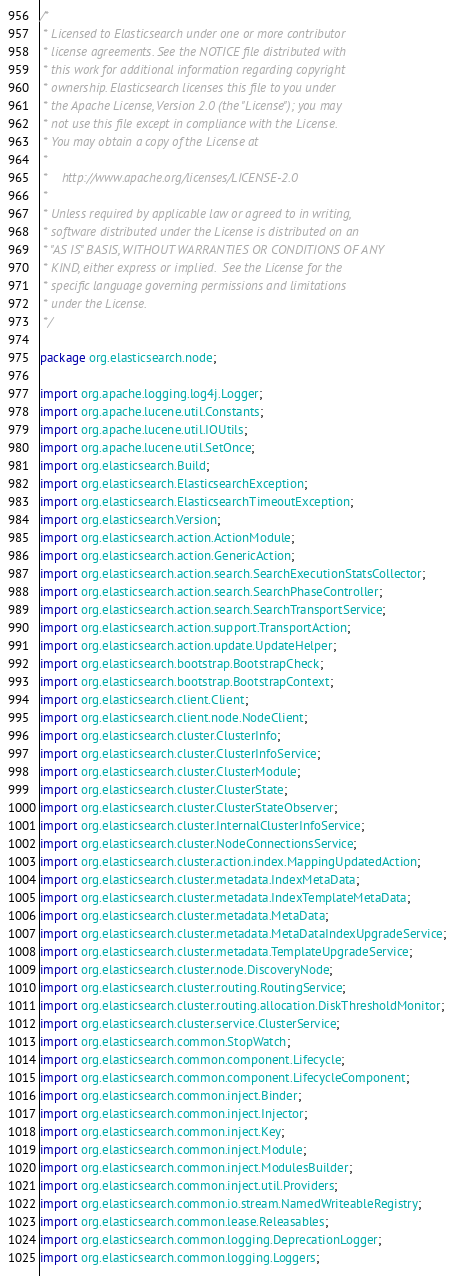Convert code to text. <code><loc_0><loc_0><loc_500><loc_500><_Java_>/*
 * Licensed to Elasticsearch under one or more contributor
 * license agreements. See the NOTICE file distributed with
 * this work for additional information regarding copyright
 * ownership. Elasticsearch licenses this file to you under
 * the Apache License, Version 2.0 (the "License"); you may
 * not use this file except in compliance with the License.
 * You may obtain a copy of the License at
 *
 *    http://www.apache.org/licenses/LICENSE-2.0
 *
 * Unless required by applicable law or agreed to in writing,
 * software distributed under the License is distributed on an
 * "AS IS" BASIS, WITHOUT WARRANTIES OR CONDITIONS OF ANY
 * KIND, either express or implied.  See the License for the
 * specific language governing permissions and limitations
 * under the License.
 */

package org.elasticsearch.node;

import org.apache.logging.log4j.Logger;
import org.apache.lucene.util.Constants;
import org.apache.lucene.util.IOUtils;
import org.apache.lucene.util.SetOnce;
import org.elasticsearch.Build;
import org.elasticsearch.ElasticsearchException;
import org.elasticsearch.ElasticsearchTimeoutException;
import org.elasticsearch.Version;
import org.elasticsearch.action.ActionModule;
import org.elasticsearch.action.GenericAction;
import org.elasticsearch.action.search.SearchExecutionStatsCollector;
import org.elasticsearch.action.search.SearchPhaseController;
import org.elasticsearch.action.search.SearchTransportService;
import org.elasticsearch.action.support.TransportAction;
import org.elasticsearch.action.update.UpdateHelper;
import org.elasticsearch.bootstrap.BootstrapCheck;
import org.elasticsearch.bootstrap.BootstrapContext;
import org.elasticsearch.client.Client;
import org.elasticsearch.client.node.NodeClient;
import org.elasticsearch.cluster.ClusterInfo;
import org.elasticsearch.cluster.ClusterInfoService;
import org.elasticsearch.cluster.ClusterModule;
import org.elasticsearch.cluster.ClusterState;
import org.elasticsearch.cluster.ClusterStateObserver;
import org.elasticsearch.cluster.InternalClusterInfoService;
import org.elasticsearch.cluster.NodeConnectionsService;
import org.elasticsearch.cluster.action.index.MappingUpdatedAction;
import org.elasticsearch.cluster.metadata.IndexMetaData;
import org.elasticsearch.cluster.metadata.IndexTemplateMetaData;
import org.elasticsearch.cluster.metadata.MetaData;
import org.elasticsearch.cluster.metadata.MetaDataIndexUpgradeService;
import org.elasticsearch.cluster.metadata.TemplateUpgradeService;
import org.elasticsearch.cluster.node.DiscoveryNode;
import org.elasticsearch.cluster.routing.RoutingService;
import org.elasticsearch.cluster.routing.allocation.DiskThresholdMonitor;
import org.elasticsearch.cluster.service.ClusterService;
import org.elasticsearch.common.StopWatch;
import org.elasticsearch.common.component.Lifecycle;
import org.elasticsearch.common.component.LifecycleComponent;
import org.elasticsearch.common.inject.Binder;
import org.elasticsearch.common.inject.Injector;
import org.elasticsearch.common.inject.Key;
import org.elasticsearch.common.inject.Module;
import org.elasticsearch.common.inject.ModulesBuilder;
import org.elasticsearch.common.inject.util.Providers;
import org.elasticsearch.common.io.stream.NamedWriteableRegistry;
import org.elasticsearch.common.lease.Releasables;
import org.elasticsearch.common.logging.DeprecationLogger;
import org.elasticsearch.common.logging.Loggers;</code> 